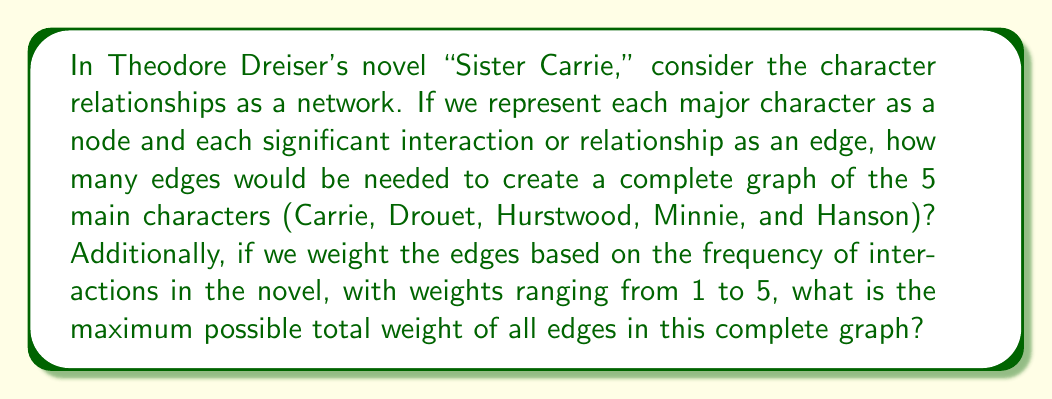Can you solve this math problem? To solve this problem, we need to apply concepts from graph theory, a branch of mathematics often used in network analysis.

1. Number of edges in a complete graph:
   In a complete graph, every node is connected to every other node. The formula for the number of edges in a complete graph with n nodes is:

   $$E = \frac{n(n-1)}{2}$$

   Where E is the number of edges and n is the number of nodes.
   In this case, n = 5 (for the 5 main characters).

   $$E = \frac{5(5-1)}{2} = \frac{5(4)}{2} = \frac{20}{2} = 10$$

2. Maximum total weight:
   The maximum weight for each edge is 5, as stated in the question. To find the maximum possible total weight, we multiply the number of edges by the maximum weight:

   $$\text{Maximum Total Weight} = E \times \text{Maximum Weight per Edge}$$
   $$\text{Maximum Total Weight} = 10 \times 5 = 50$$

This approach allows us to quantify the complexity of character relationships in Dreiser's novel using network theory, providing a mathematical perspective on literary analysis.
Answer: The complete graph would have 10 edges, and the maximum possible total weight of all edges is 50. 